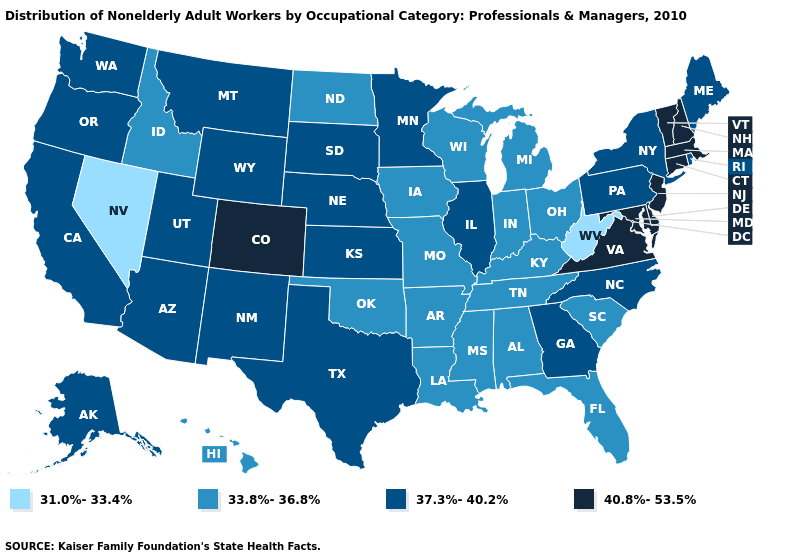What is the highest value in the USA?
Quick response, please. 40.8%-53.5%. Which states have the lowest value in the USA?
Answer briefly. Nevada, West Virginia. What is the lowest value in the West?
Keep it brief. 31.0%-33.4%. Does New Hampshire have the highest value in the Northeast?
Give a very brief answer. Yes. What is the value of Texas?
Write a very short answer. 37.3%-40.2%. How many symbols are there in the legend?
Be succinct. 4. Name the states that have a value in the range 33.8%-36.8%?
Short answer required. Alabama, Arkansas, Florida, Hawaii, Idaho, Indiana, Iowa, Kentucky, Louisiana, Michigan, Mississippi, Missouri, North Dakota, Ohio, Oklahoma, South Carolina, Tennessee, Wisconsin. What is the highest value in states that border Maryland?
Be succinct. 40.8%-53.5%. Among the states that border Texas , does New Mexico have the lowest value?
Concise answer only. No. Which states have the lowest value in the MidWest?
Quick response, please. Indiana, Iowa, Michigan, Missouri, North Dakota, Ohio, Wisconsin. What is the highest value in states that border New Mexico?
Answer briefly. 40.8%-53.5%. Name the states that have a value in the range 37.3%-40.2%?
Be succinct. Alaska, Arizona, California, Georgia, Illinois, Kansas, Maine, Minnesota, Montana, Nebraska, New Mexico, New York, North Carolina, Oregon, Pennsylvania, Rhode Island, South Dakota, Texas, Utah, Washington, Wyoming. Among the states that border Wyoming , does Idaho have the lowest value?
Quick response, please. Yes. Name the states that have a value in the range 33.8%-36.8%?
Short answer required. Alabama, Arkansas, Florida, Hawaii, Idaho, Indiana, Iowa, Kentucky, Louisiana, Michigan, Mississippi, Missouri, North Dakota, Ohio, Oklahoma, South Carolina, Tennessee, Wisconsin. Which states have the lowest value in the USA?
Be succinct. Nevada, West Virginia. 